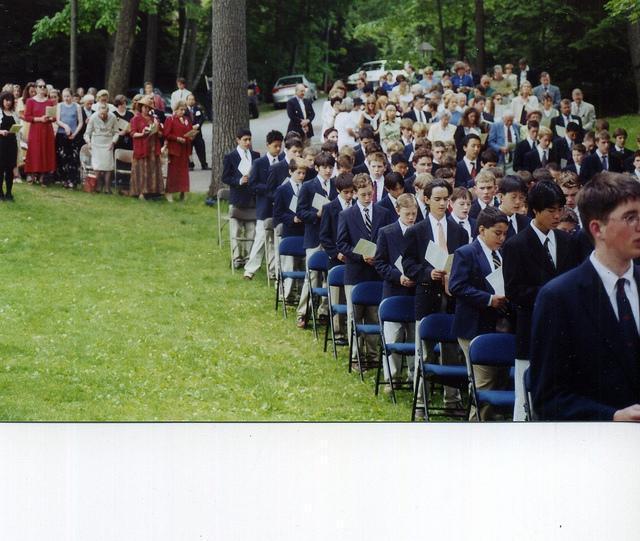How many people are there?
Give a very brief answer. 12. How many chairs are in the picture?
Give a very brief answer. 3. How many human statues are to the left of the clock face?
Give a very brief answer. 0. 